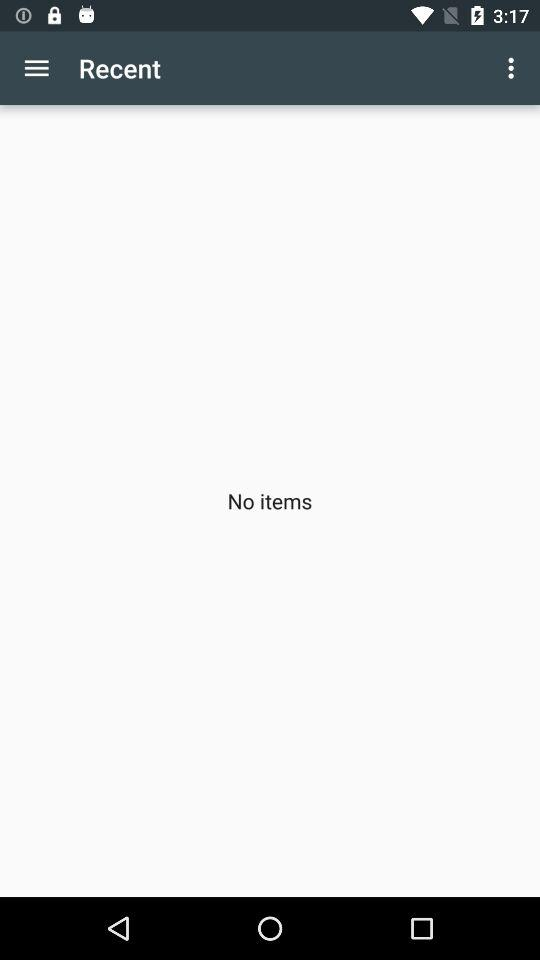Is there any item? There is no item. 